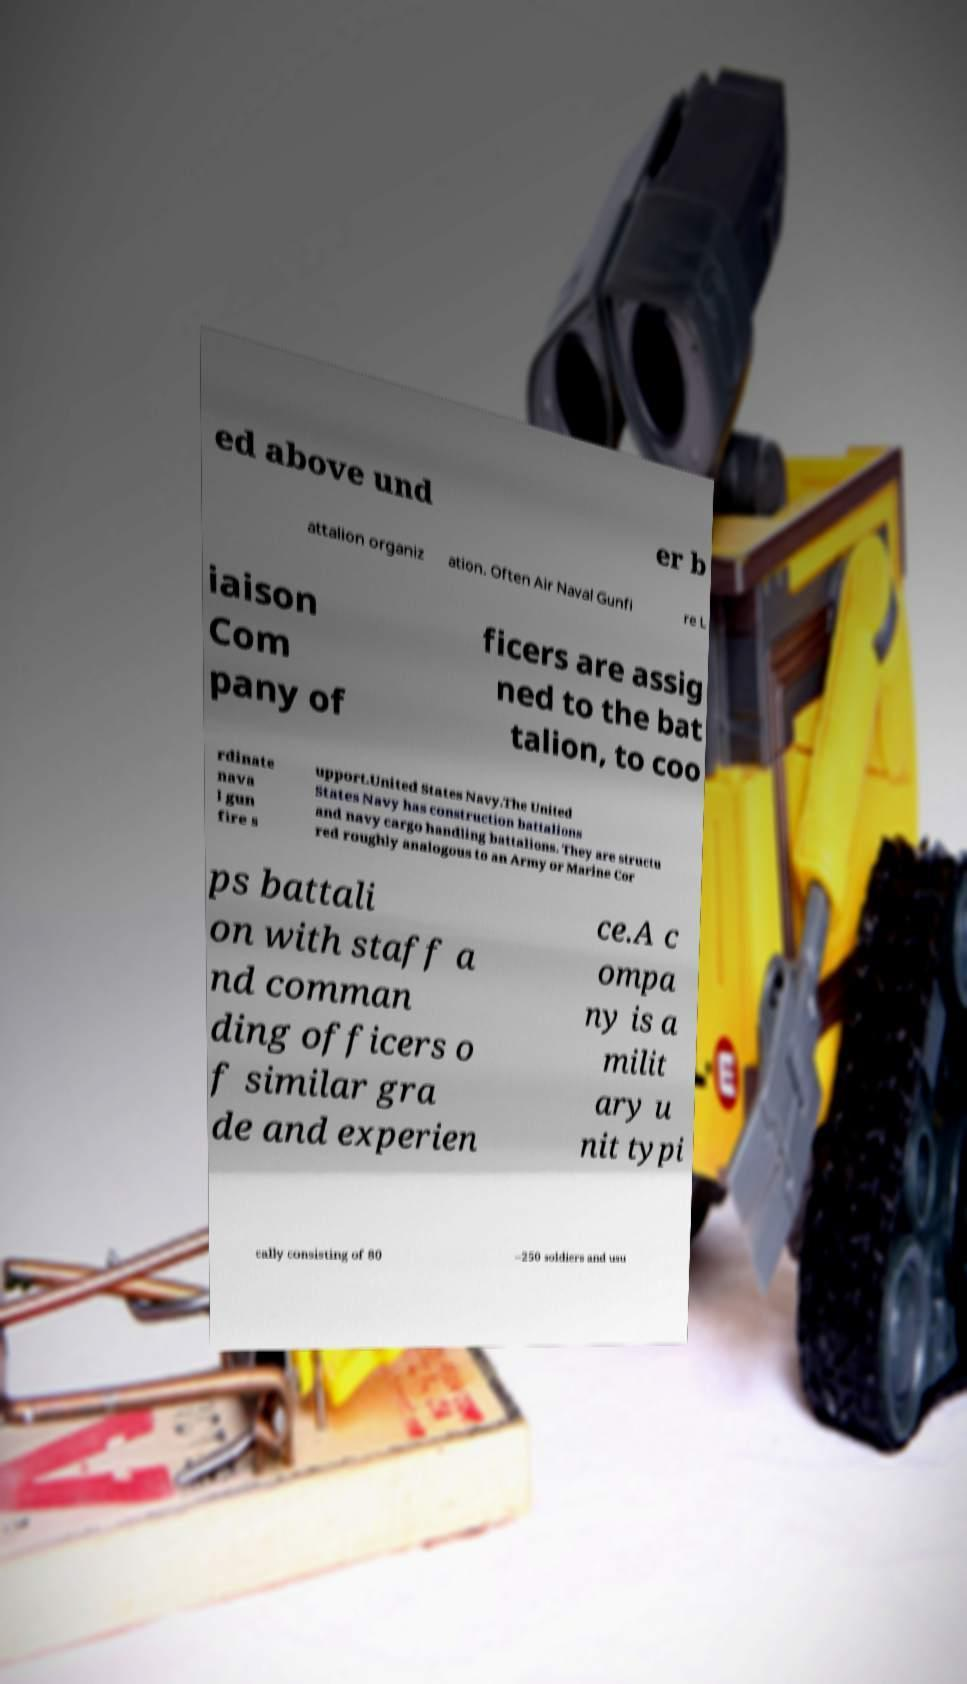Can you accurately transcribe the text from the provided image for me? ed above und er b attalion organiz ation. Often Air Naval Gunfi re L iaison Com pany of ficers are assig ned to the bat talion, to coo rdinate nava l gun fire s upport.United States Navy.The United States Navy has construction battalions and navy cargo handling battalions. They are structu red roughly analogous to an Army or Marine Cor ps battali on with staff a nd comman ding officers o f similar gra de and experien ce.A c ompa ny is a milit ary u nit typi cally consisting of 80 –250 soldiers and usu 